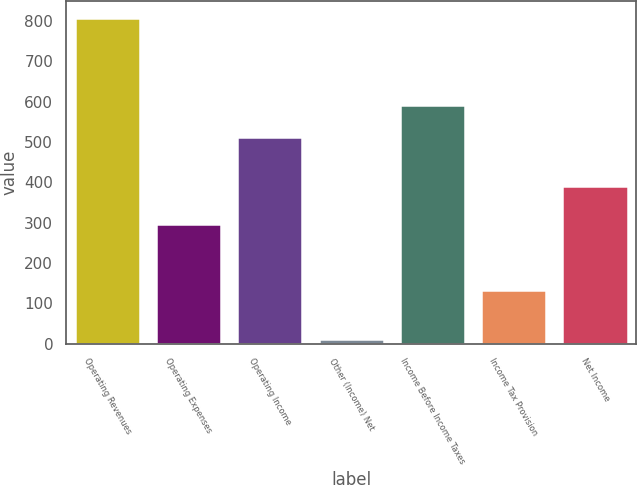Convert chart to OTSL. <chart><loc_0><loc_0><loc_500><loc_500><bar_chart><fcel>Operating Revenues<fcel>Operating Expenses<fcel>Operating Income<fcel>Other (Income) Net<fcel>Income Before Income Taxes<fcel>Income Tax Provision<fcel>Net Income<nl><fcel>809<fcel>296<fcel>513<fcel>12<fcel>592.7<fcel>133<fcel>392<nl></chart> 